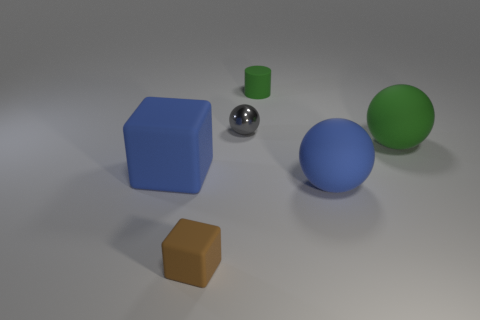What shape is the matte thing that is the same color as the large block?
Keep it short and to the point. Sphere. What size is the cylinder?
Offer a very short reply. Small. How many gray things have the same size as the blue block?
Offer a very short reply. 0. There is a rubber sphere that is in front of the large green thing; is its size the same as the blue matte thing that is on the left side of the green cylinder?
Your answer should be very brief. Yes. What shape is the blue thing on the right side of the brown matte object?
Keep it short and to the point. Sphere. There is a green thing that is to the right of the blue matte thing that is on the right side of the small brown rubber object; what is its material?
Keep it short and to the point. Rubber. Are there any small balls that have the same color as the matte cylinder?
Offer a very short reply. No. Does the gray object have the same size as the blue matte thing that is left of the small green object?
Keep it short and to the point. No. How many big matte objects are on the left side of the blue rubber thing that is right of the big thing that is on the left side of the tiny metallic thing?
Ensure brevity in your answer.  1. What number of small cylinders are to the left of the brown cube?
Offer a very short reply. 0. 